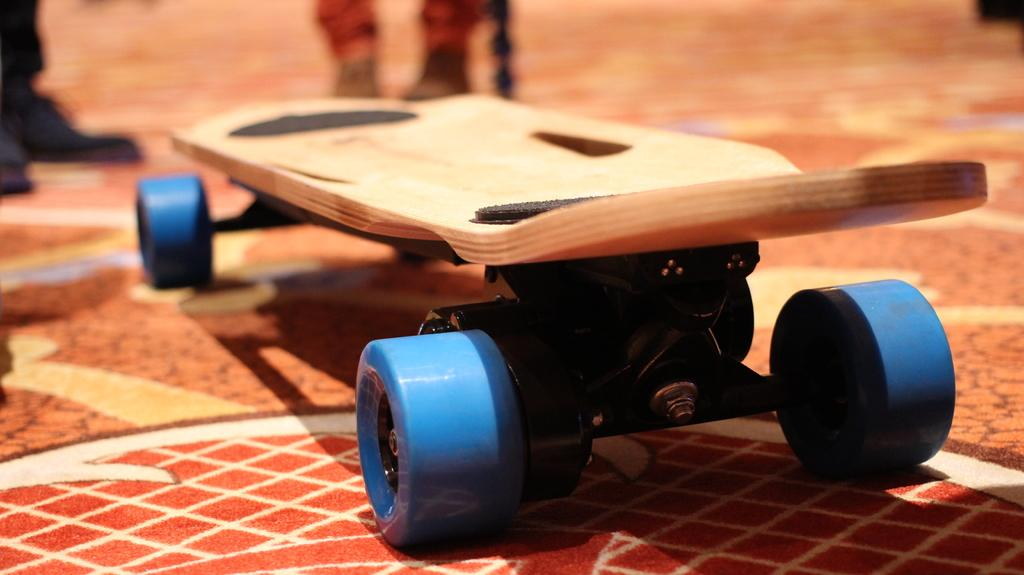What object is the main focus of the image? There is a skateboard in the image. Can you describe the surroundings of the skateboard? The legs of people are visible behind the skateboard. What is on the floor in the image? There is a mat on the floor in the image. What type of oven is visible in the image? There is no oven present in the image. What kind of van can be seen parked next to the skateboard? There is no van present in the image. 